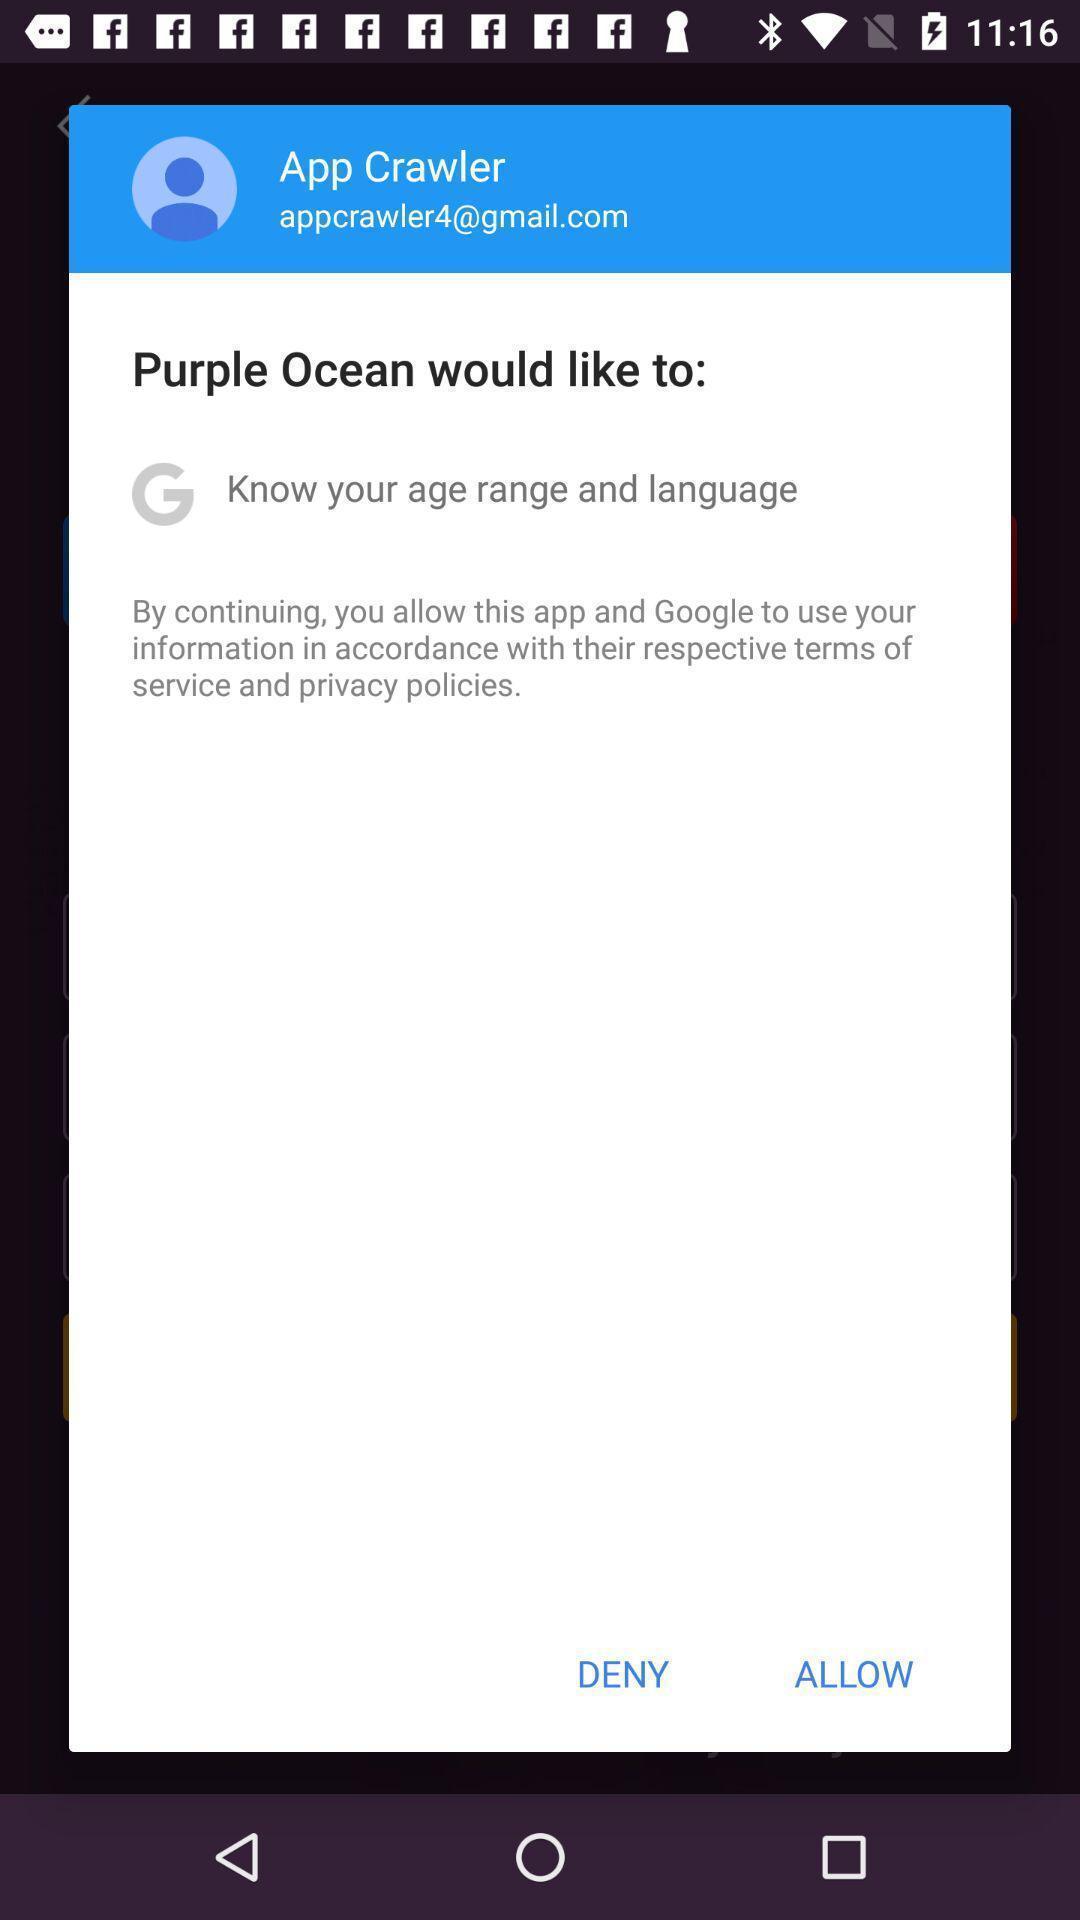What can you discern from this picture? Screen displaying to allow this application. 